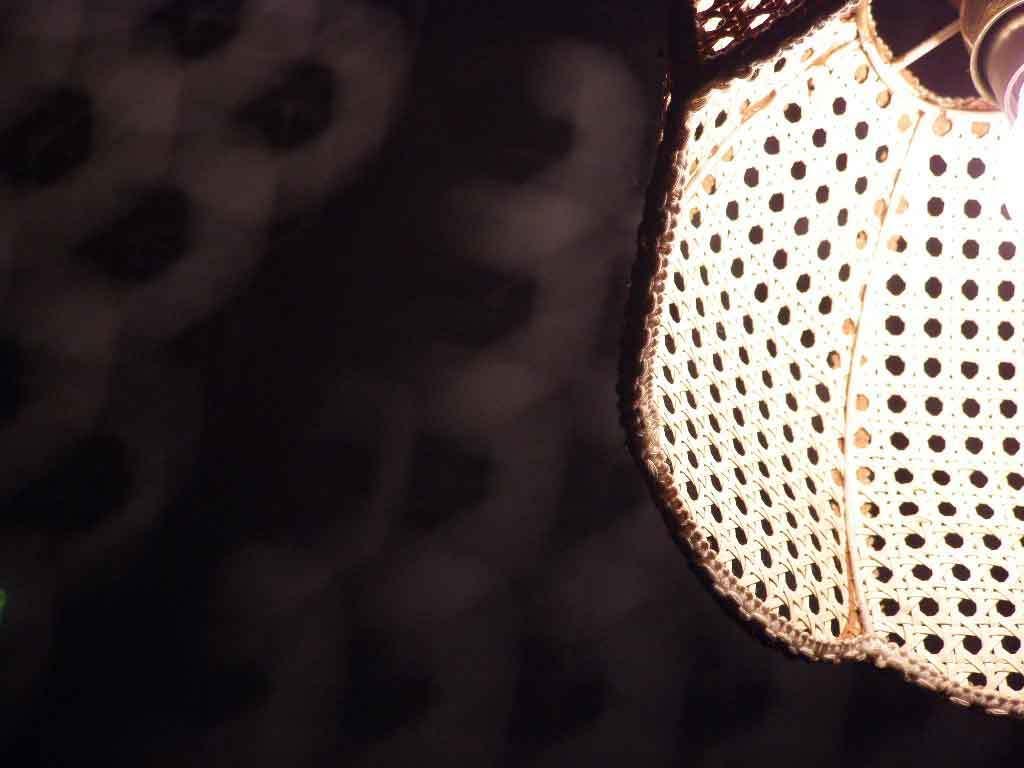Can you describe this image briefly? In this picture we can see an object and in the background we can see it is blurry. 